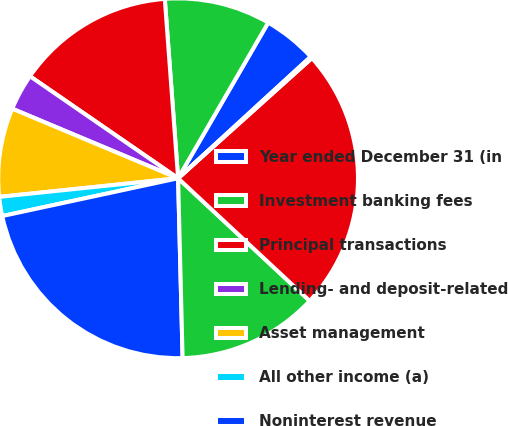Convert chart to OTSL. <chart><loc_0><loc_0><loc_500><loc_500><pie_chart><fcel>Year ended December 31 (in<fcel>Investment banking fees<fcel>Principal transactions<fcel>Lending- and deposit-related<fcel>Asset management<fcel>All other income (a)<fcel>Noninterest revenue<fcel>Net interest income (a)<fcel>Total net revenue<fcel>Provision for credit losses<nl><fcel>4.84%<fcel>9.53%<fcel>14.22%<fcel>3.28%<fcel>7.97%<fcel>1.72%<fcel>22.03%<fcel>12.66%<fcel>23.59%<fcel>0.16%<nl></chart> 